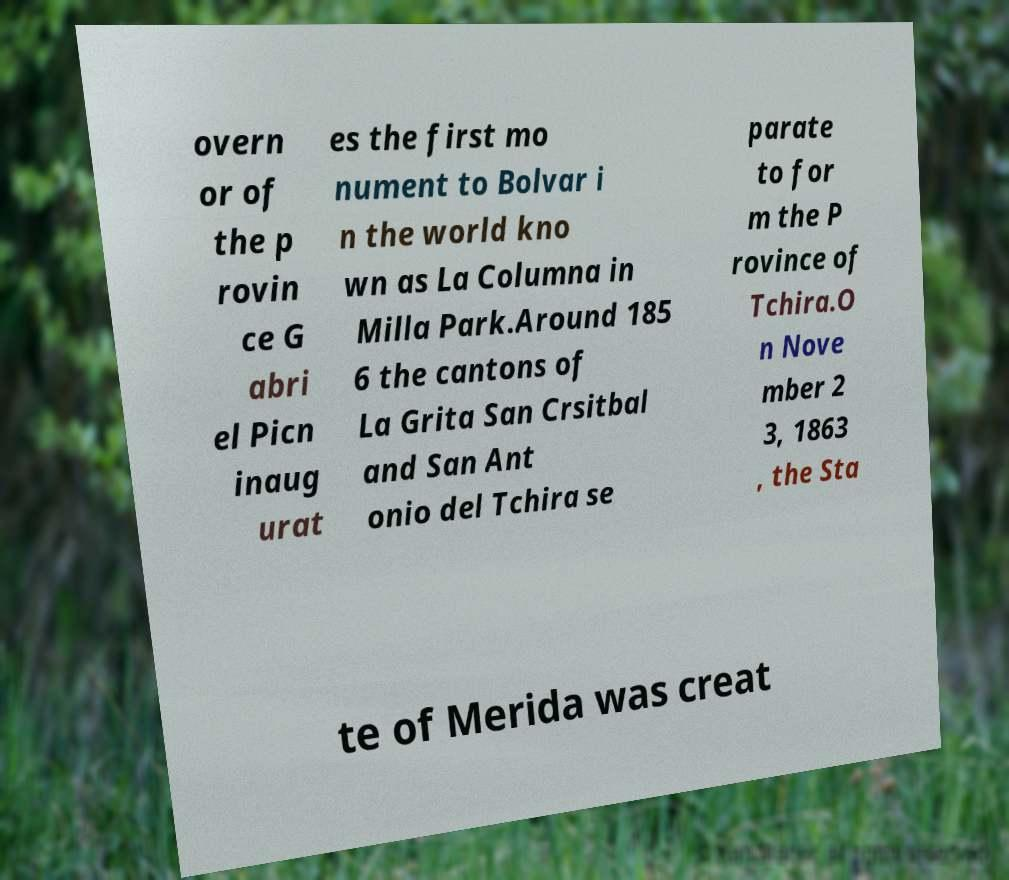For documentation purposes, I need the text within this image transcribed. Could you provide that? overn or of the p rovin ce G abri el Picn inaug urat es the first mo nument to Bolvar i n the world kno wn as La Columna in Milla Park.Around 185 6 the cantons of La Grita San Crsitbal and San Ant onio del Tchira se parate to for m the P rovince of Tchira.O n Nove mber 2 3, 1863 , the Sta te of Merida was creat 